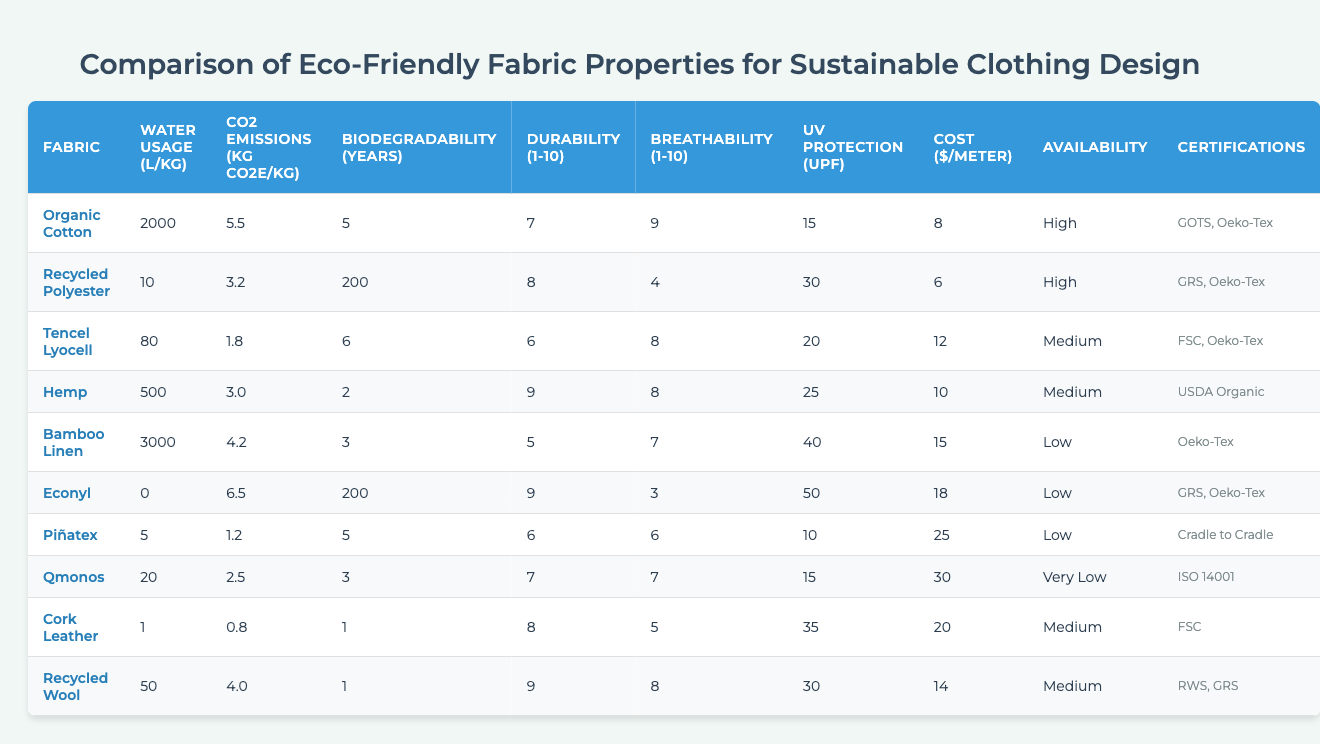What fabric has the lowest water usage? By examining the "Water Usage (L/kg)" column, we see that "Econyl" has 0 L/kg, which is the lowest value in the table.
Answer: Econyl Which fabric has the highest CO2 emissions? Looking at the "CO2 Emissions (kg CO2e/kg)" column, "Econyl" has the highest emissions at 6.5 kg CO2e/kg.
Answer: Econyl What is the average biodegradability of the fabrics listed? To find the average, we sum up all the biodegradability values (5 + 200 + 6 + 2 + 3 + 200 + 5 + 3 + 1 + 1 = 426) and divide by 10 (number of fabrics). So, 426 / 10 = 42.6 years.
Answer: 42.6 years Is "Hemp" the most durable fabric? By checking the "Durability (1-10 scale)" column, "Hemp" has a score of 9. Comparing it with others, several others also have 9, so it is not unique.
Answer: No Which fabric is the most breathable? In the "Breathability (1-10 scale)" column, "Organic Cotton" has the highest score of 9, making it the most breathable fabric on the list.
Answer: Organic Cotton What is the cost difference between "Bamboo Linen" and "Piñatex"? From the "Cost ($/meter)" column, "Bamboo Linen" costs $15 and "Piñatex" costs $25. The difference is $25 - $15 = $10.
Answer: $10 Which fabrics have high availability? Referring to the "Availability" column, "Organic Cotton" and "Recycled Polyester" both have "High" availability.
Answer: Organic Cotton, Recycled Polyester What is the median durability score of the fabrics? To find the median, we list the durability scores in order: (5, 5, 6, 6, 7, 7, 8, 8, 9, 9). The median is the average of the 5th and 6th values: (7 + 7) / 2 = 7.
Answer: 7 How many fabrics have a biodegradability of less than 5 years? Checking the "Biodegradability (years)" column, fabrics with less than 5 years are "Hemp", "Bamboo Linen", "Recycled Wool" (1 year each). So, there are 4 fabrics that meet this criterion.
Answer: 4 Is the UV protection of "Bamboo Linen" higher than that of "Cork Leather"? Looking at the "UV Protection (UPF)" column, "Bamboo Linen" has 40 UPF and "Cork Leather" has 15 UPF. Since 40 > 15, that means "Bamboo Linen" does have higher UV protection.
Answer: Yes 